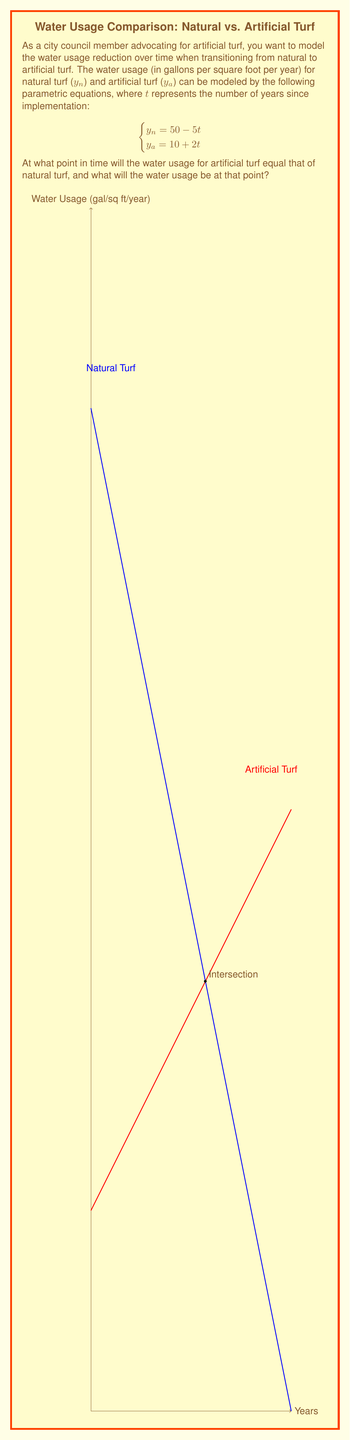Teach me how to tackle this problem. To solve this problem, we need to find the point where the water usage for both types of turf is equal. This occurs when $y_n = y_a$.

Step 1: Set up the equation
$50 - 5t = 10 + 2t$

Step 2: Solve for $t$
$40 = 7t$
$t = \frac{40}{7} \approx 5.71$ years

Step 3: Calculate the water usage at this point
Substitute $t = \frac{40}{7}$ into either equation:

$y_n = 50 - 5(\frac{40}{7}) = 50 - \frac{200}{7} = \frac{150}{7} \approx 21.43$ gallons per square foot per year

or

$y_a = 10 + 2(\frac{40}{7}) = 10 + \frac{80}{7} = \frac{150}{7} \approx 21.43$ gallons per square foot per year

Therefore, the water usage for artificial turf will equal that of natural turf after approximately 5.71 years, at which point the water usage will be about 21.43 gallons per square foot per year.
Answer: $(\frac{40}{7}, \frac{150}{7}) \approx (5.71, 21.43)$ 